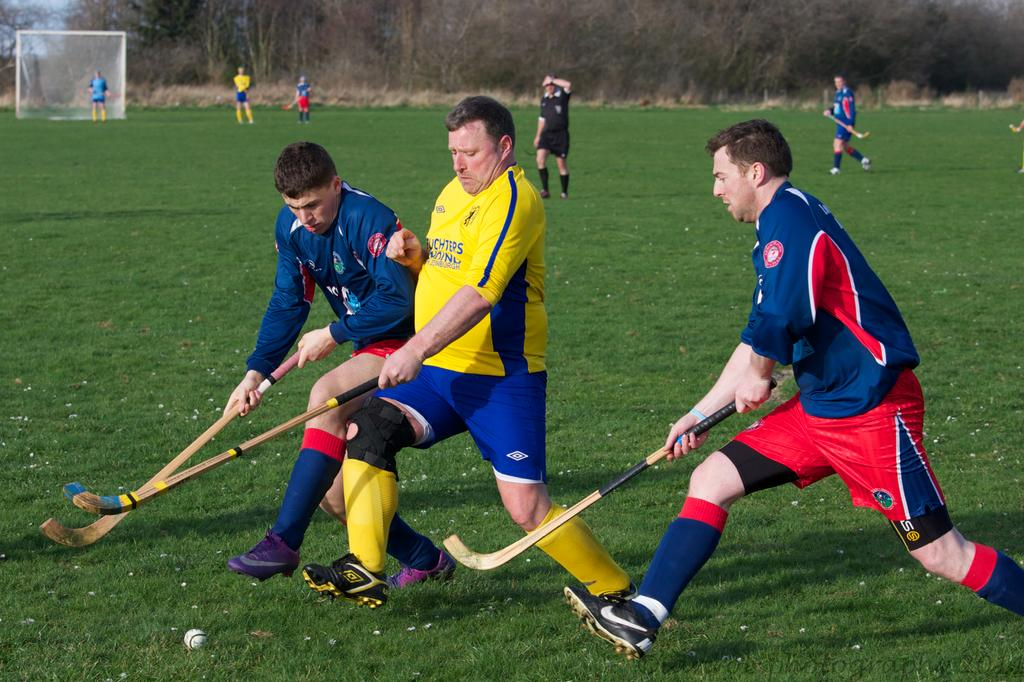What are the people in the image doing? There is a group of people on the ground, and some of them are holding sticks. What object can be seen in the image besides the people and sticks? There is a ball visible in the image. What can be seen in the background of the image? There are trees and grass in the background of the image, as well as an object. Can you describe the object in the background? Unfortunately, the facts provided do not give enough information to describe the object in the background. What type of noise can be heard coming from the rings in the image? There are no rings present in the image, so it is not possible to determine what type of noise might be heard. 